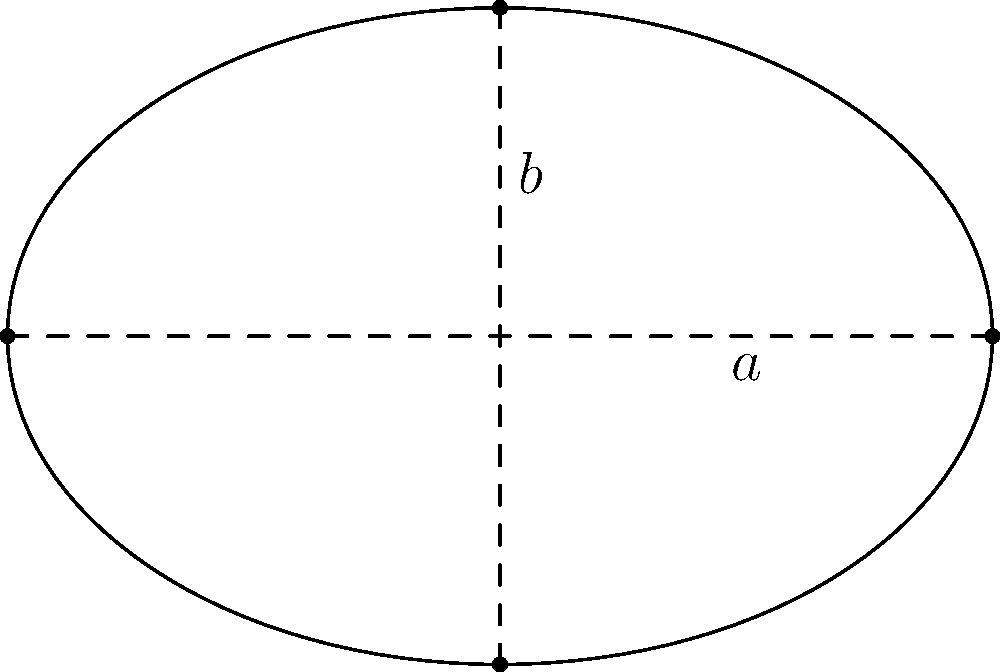As an AI enthusiast developing an interactive model of the solar system, you're working on simulating planetary orbits. Consider an elliptical orbit with a semi-major axis $a = 3$ units and a semi-minor axis $b = 2$ units. Calculate the area enclosed by this orbit. To calculate the area of an ellipse, we can use the formula:

$$ A = \pi ab $$

Where:
- $A$ is the area of the ellipse
- $a$ is the length of the semi-major axis
- $b$ is the length of the semi-minor axis

Given:
- Semi-major axis $a = 3$ units
- Semi-minor axis $b = 2$ units

Step 1: Substitute the values into the formula
$$ A = \pi \cdot 3 \cdot 2 $$

Step 2: Simplify
$$ A = 6\pi $$

Therefore, the area enclosed by the elliptical orbit is $6\pi$ square units.
Answer: $6\pi$ square units 